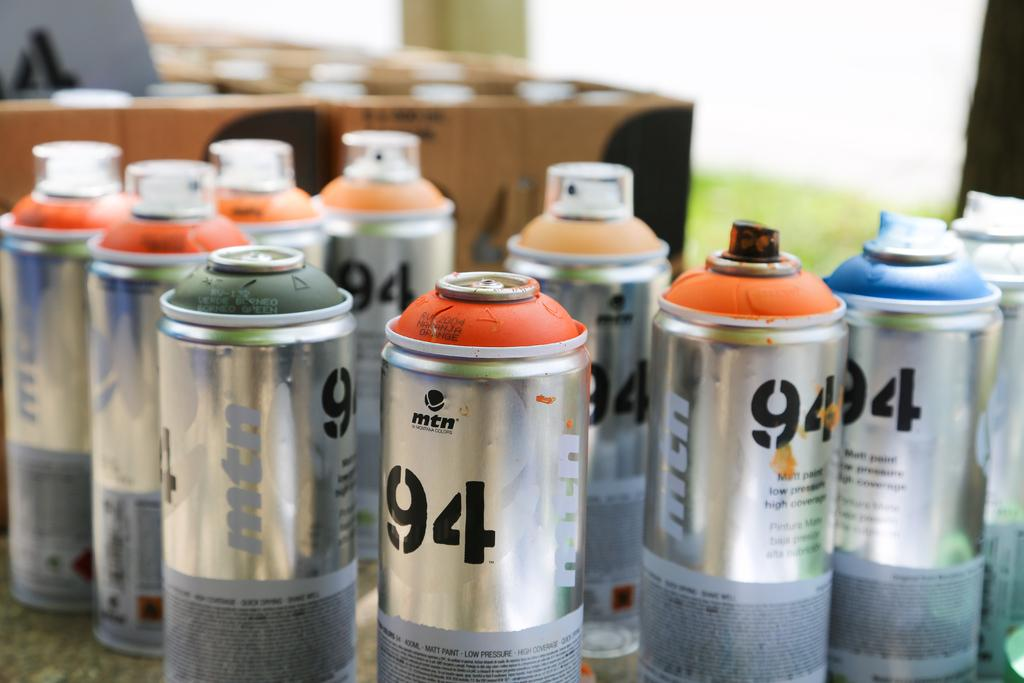<image>
Create a compact narrative representing the image presented. Several spray can sitting on the table many with the number 94 on them. 